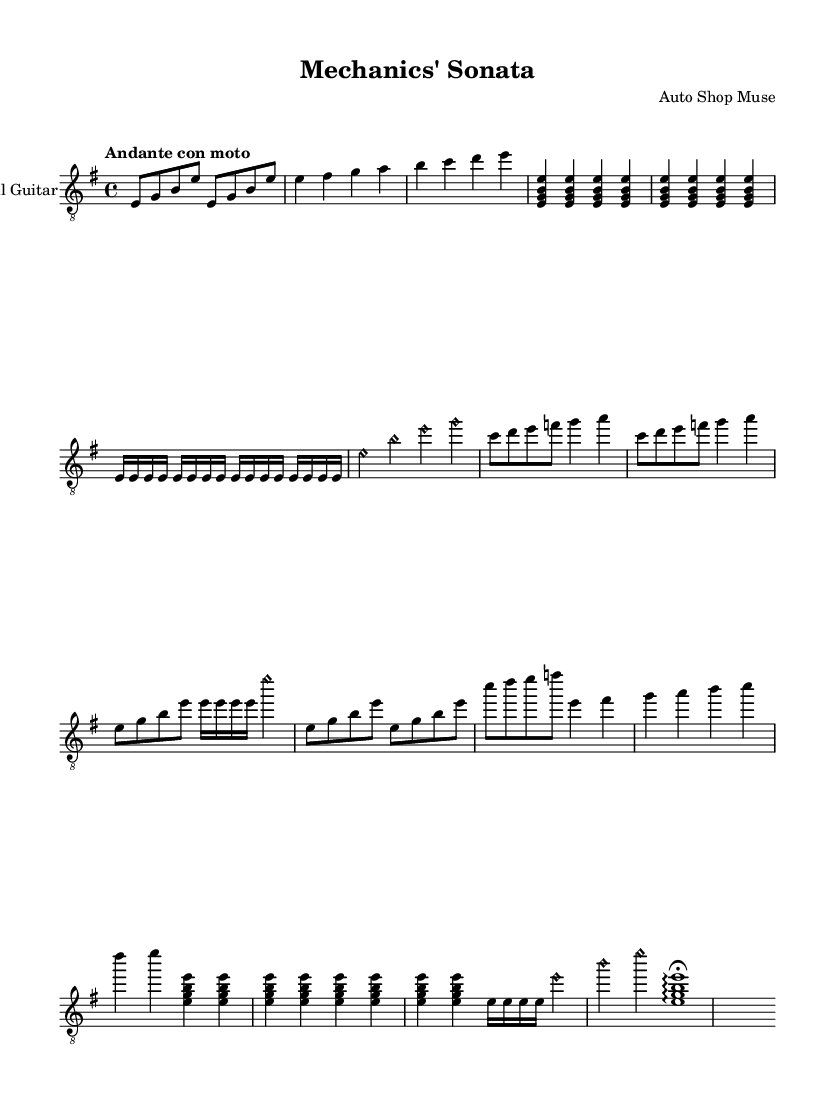What is the key signature of this music? The key signature is E minor, which has one sharp (F#). This can be determined by looking for the sharps indicated at the beginning of the staff.
Answer: E minor What is the time signature of this piece? The time signature is 4/4, shown at the beginning of the score. This means there are four beats in each measure, and the quarter note gets one beat.
Answer: 4/4 What is the tempo marking for this piece? The tempo marking is "Andante con moto," indicating a moderately slow tempo with a bit of movement. This is typically noted at the beginning of the music to guide the performer on the speed of the piece.
Answer: Andante con moto How many times is the "Engine Idling Ostinato" repeated? The "Engine Idling Ostinato" section is repeated twice, as indicated by the "repeat unfold 2" instruction in the music. This shows the performer to play that section two times for emphasis.
Answer: 2 Identify the instrument for this score. The instrument indicated at the beginning of the music is "Classical Guitar." This is often noted at the start of the sheet music to clarify which instrument is to perform the piece.
Answer: Classical Guitar What happens in the "Coda" section? The "Coda" section features a sequence of notes similar to a flourish that concludes the piece, ending with an arpeggiated chord and a fermata, indicating to hold the last note. This can be seen in how the notes and markings are arranged at the end.
Answer: Arpeggio with fermata What is a melodic feature of "Theme A"? "Theme A" consists of a stepwise rising melody, moving from E to A, outlining a wrench-turning motif, resembling a mechanical movement. This can be observed in the notes written in sequence and their logical ascent.
Answer: Stepwise rising melody 